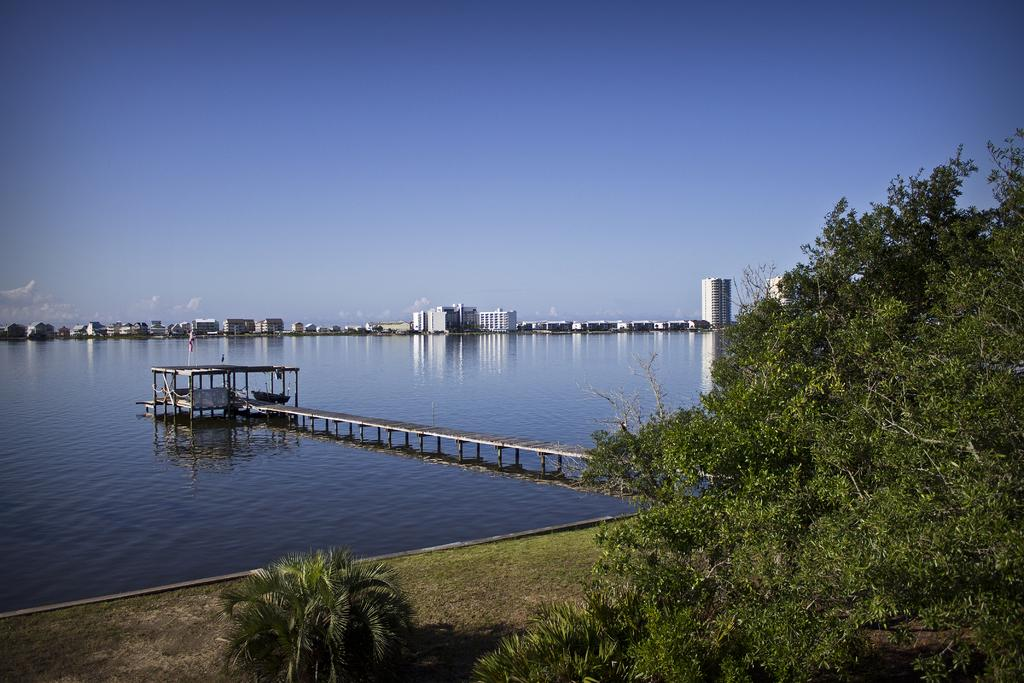What type of vegetation can be seen in the image? There are small plants and trees in the image. What type of structure is present in the image? There is a bridge in the image. What else can be seen in the image besides vegetation and the bridge? There are buildings in the image. What is visible in the background of the image? The sky is visible in the background of the image, and there are clouds in the sky. What color is the paint on the finger in the image? There is no paint or finger present in the image. How many bits can be seen in the image? There are no bits present in the image. 